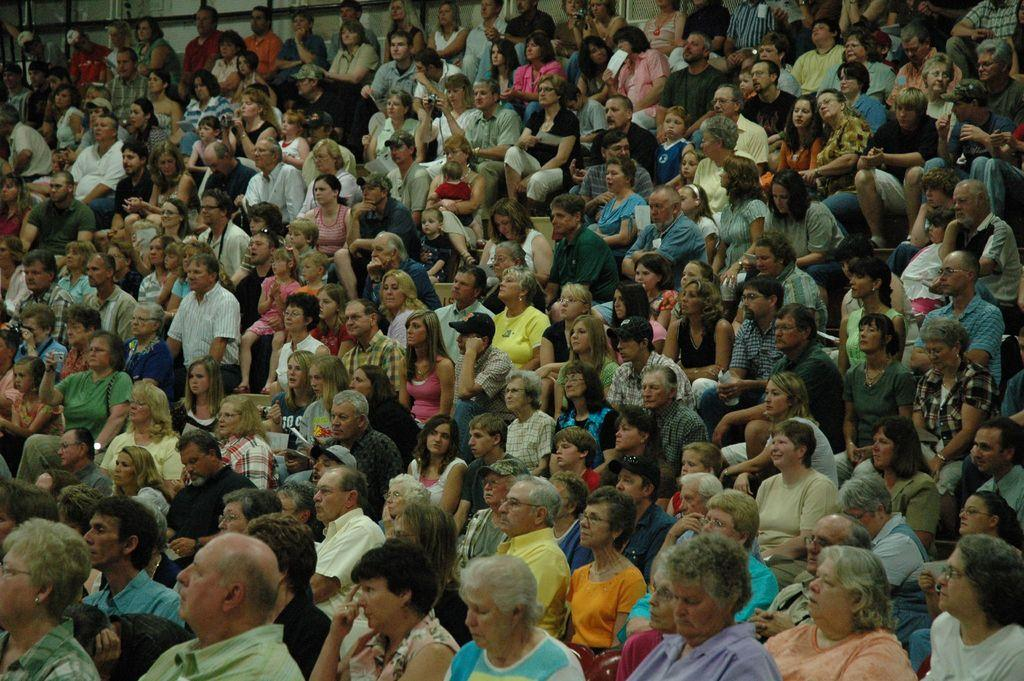What are the people in the image doing? There are people sitting in the image. What objects are some people holding in the image? Some people are holding cameras in the image. Can you see a snake slithering near the people in the image? There is no snake present in the image. Are there any icicles hanging from the people's clothing in the image? There are no icicles present in the image. 